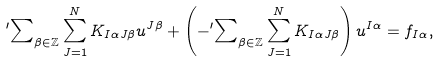<formula> <loc_0><loc_0><loc_500><loc_500>{ ^ { \prime } } { \sum } _ { \beta \in \mathbb { Z } } \sum _ { J = 1 } ^ { N } K _ { I \alpha J \beta } u ^ { J \beta } + \left ( - { ^ { \prime } } { \sum } _ { \beta \in \mathbb { Z } } \sum _ { J = 1 } ^ { N } K _ { I \alpha J \beta } \right ) u ^ { I \alpha } = f _ { I \alpha } ,</formula> 